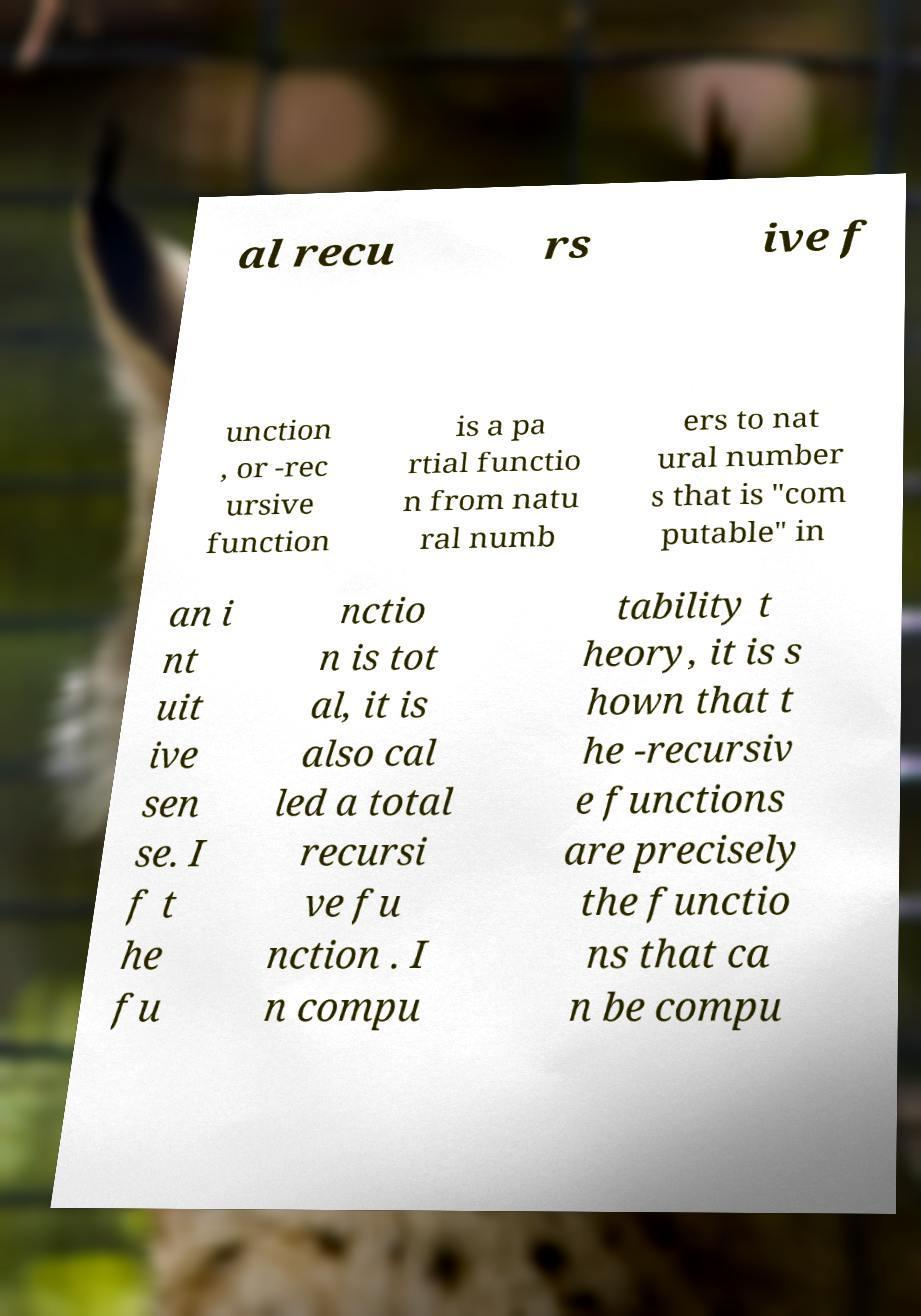Please read and relay the text visible in this image. What does it say? al recu rs ive f unction , or -rec ursive function is a pa rtial functio n from natu ral numb ers to nat ural number s that is "com putable" in an i nt uit ive sen se. I f t he fu nctio n is tot al, it is also cal led a total recursi ve fu nction . I n compu tability t heory, it is s hown that t he -recursiv e functions are precisely the functio ns that ca n be compu 